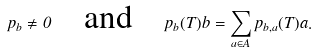<formula> <loc_0><loc_0><loc_500><loc_500>p _ { b } \neq 0 \quad \text {and} \quad p _ { b } ( T ) b = \sum _ { a \in A } p _ { b , a } ( T ) a .</formula> 